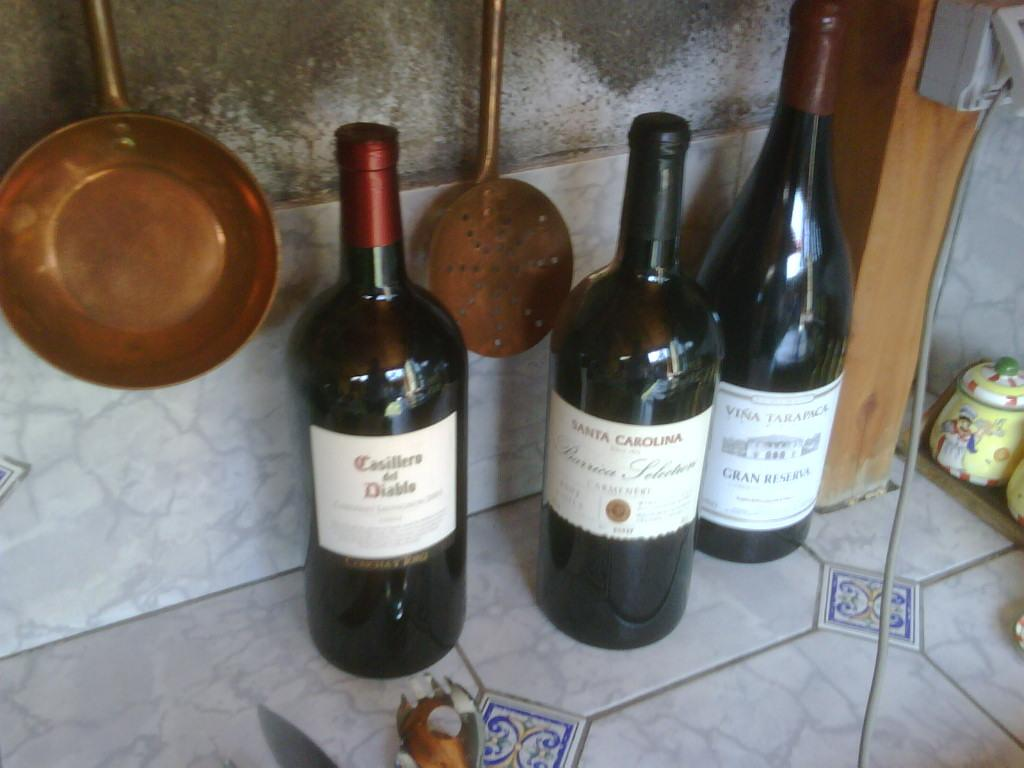Provide a one-sentence caption for the provided image. Three bottles of wine including one from Santa Carolina sit on a counter. 